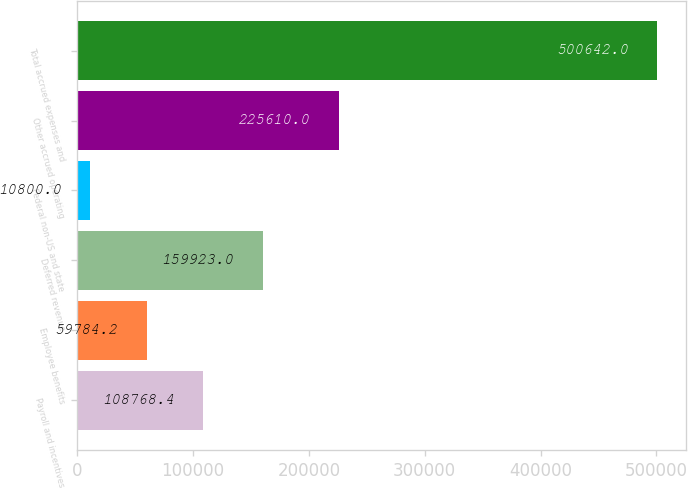Convert chart. <chart><loc_0><loc_0><loc_500><loc_500><bar_chart><fcel>Payroll and incentives<fcel>Employee benefits<fcel>Deferred revenue<fcel>Federal non-US and state<fcel>Other accrued operating<fcel>Total accrued expenses and<nl><fcel>108768<fcel>59784.2<fcel>159923<fcel>10800<fcel>225610<fcel>500642<nl></chart> 